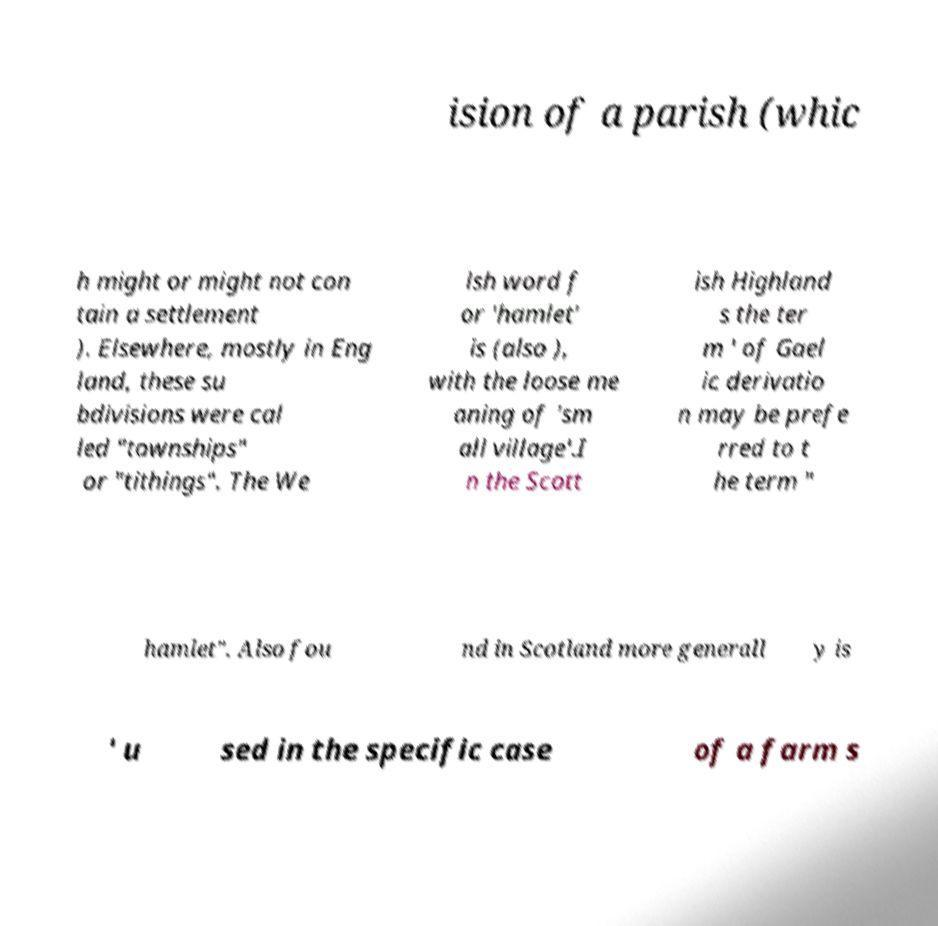I need the written content from this picture converted into text. Can you do that? ision of a parish (whic h might or might not con tain a settlement ). Elsewhere, mostly in Eng land, these su bdivisions were cal led "townships" or "tithings". The We lsh word f or 'hamlet' is (also ), with the loose me aning of 'sm all village'.I n the Scott ish Highland s the ter m ' of Gael ic derivatio n may be prefe rred to t he term " hamlet". Also fou nd in Scotland more generall y is ' u sed in the specific case of a farm s 